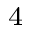Convert formula to latex. <formula><loc_0><loc_0><loc_500><loc_500>^ { 4 }</formula> 